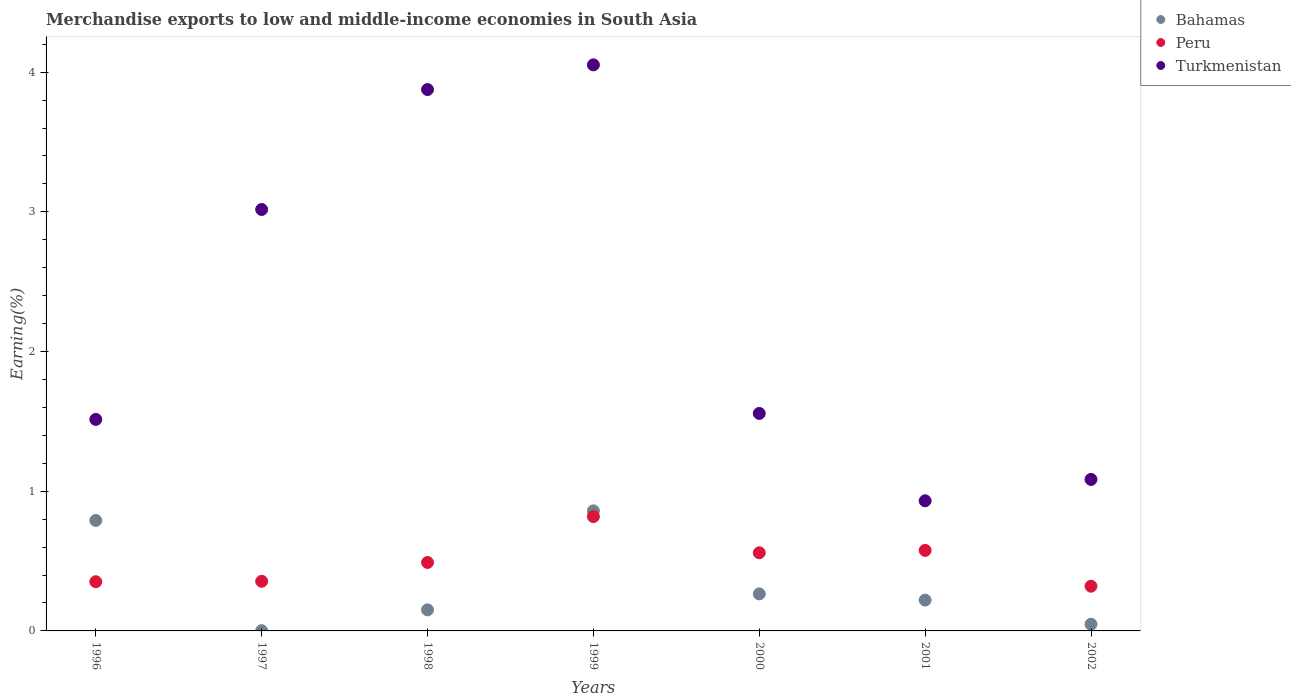How many different coloured dotlines are there?
Offer a terse response. 3. Is the number of dotlines equal to the number of legend labels?
Provide a succinct answer. Yes. What is the percentage of amount earned from merchandise exports in Peru in 1996?
Your answer should be very brief. 0.35. Across all years, what is the maximum percentage of amount earned from merchandise exports in Peru?
Keep it short and to the point. 0.82. Across all years, what is the minimum percentage of amount earned from merchandise exports in Bahamas?
Offer a terse response. 0. In which year was the percentage of amount earned from merchandise exports in Bahamas minimum?
Offer a terse response. 1997. What is the total percentage of amount earned from merchandise exports in Bahamas in the graph?
Your answer should be compact. 2.34. What is the difference between the percentage of amount earned from merchandise exports in Turkmenistan in 1996 and that in 2000?
Keep it short and to the point. -0.04. What is the difference between the percentage of amount earned from merchandise exports in Turkmenistan in 1999 and the percentage of amount earned from merchandise exports in Bahamas in 2001?
Your response must be concise. 3.83. What is the average percentage of amount earned from merchandise exports in Peru per year?
Offer a very short reply. 0.5. In the year 1999, what is the difference between the percentage of amount earned from merchandise exports in Bahamas and percentage of amount earned from merchandise exports in Peru?
Your answer should be very brief. 0.04. What is the ratio of the percentage of amount earned from merchandise exports in Turkmenistan in 1998 to that in 1999?
Offer a very short reply. 0.96. What is the difference between the highest and the second highest percentage of amount earned from merchandise exports in Bahamas?
Offer a very short reply. 0.07. What is the difference between the highest and the lowest percentage of amount earned from merchandise exports in Turkmenistan?
Make the answer very short. 3.12. Does the percentage of amount earned from merchandise exports in Turkmenistan monotonically increase over the years?
Provide a succinct answer. No. Is the percentage of amount earned from merchandise exports in Bahamas strictly less than the percentage of amount earned from merchandise exports in Turkmenistan over the years?
Provide a succinct answer. Yes. How many years are there in the graph?
Make the answer very short. 7. Does the graph contain any zero values?
Give a very brief answer. No. Where does the legend appear in the graph?
Your answer should be compact. Top right. What is the title of the graph?
Ensure brevity in your answer.  Merchandise exports to low and middle-income economies in South Asia. Does "Papua New Guinea" appear as one of the legend labels in the graph?
Make the answer very short. No. What is the label or title of the Y-axis?
Make the answer very short. Earning(%). What is the Earning(%) of Bahamas in 1996?
Provide a short and direct response. 0.79. What is the Earning(%) of Peru in 1996?
Your response must be concise. 0.35. What is the Earning(%) in Turkmenistan in 1996?
Provide a succinct answer. 1.51. What is the Earning(%) in Bahamas in 1997?
Make the answer very short. 0. What is the Earning(%) of Peru in 1997?
Give a very brief answer. 0.36. What is the Earning(%) of Turkmenistan in 1997?
Your response must be concise. 3.02. What is the Earning(%) of Bahamas in 1998?
Ensure brevity in your answer.  0.15. What is the Earning(%) of Peru in 1998?
Provide a short and direct response. 0.49. What is the Earning(%) in Turkmenistan in 1998?
Keep it short and to the point. 3.88. What is the Earning(%) of Bahamas in 1999?
Your answer should be compact. 0.86. What is the Earning(%) in Peru in 1999?
Give a very brief answer. 0.82. What is the Earning(%) in Turkmenistan in 1999?
Ensure brevity in your answer.  4.05. What is the Earning(%) of Bahamas in 2000?
Ensure brevity in your answer.  0.27. What is the Earning(%) of Peru in 2000?
Provide a short and direct response. 0.56. What is the Earning(%) in Turkmenistan in 2000?
Keep it short and to the point. 1.56. What is the Earning(%) of Bahamas in 2001?
Provide a succinct answer. 0.22. What is the Earning(%) in Peru in 2001?
Keep it short and to the point. 0.58. What is the Earning(%) in Turkmenistan in 2001?
Make the answer very short. 0.93. What is the Earning(%) of Bahamas in 2002?
Your answer should be compact. 0.05. What is the Earning(%) in Peru in 2002?
Give a very brief answer. 0.32. What is the Earning(%) in Turkmenistan in 2002?
Your answer should be compact. 1.08. Across all years, what is the maximum Earning(%) in Bahamas?
Offer a very short reply. 0.86. Across all years, what is the maximum Earning(%) of Peru?
Your answer should be very brief. 0.82. Across all years, what is the maximum Earning(%) of Turkmenistan?
Keep it short and to the point. 4.05. Across all years, what is the minimum Earning(%) of Bahamas?
Your answer should be compact. 0. Across all years, what is the minimum Earning(%) of Peru?
Your answer should be very brief. 0.32. Across all years, what is the minimum Earning(%) in Turkmenistan?
Offer a terse response. 0.93. What is the total Earning(%) in Bahamas in the graph?
Provide a short and direct response. 2.34. What is the total Earning(%) in Peru in the graph?
Offer a very short reply. 3.47. What is the total Earning(%) of Turkmenistan in the graph?
Offer a terse response. 16.03. What is the difference between the Earning(%) in Bahamas in 1996 and that in 1997?
Offer a very short reply. 0.79. What is the difference between the Earning(%) of Peru in 1996 and that in 1997?
Provide a succinct answer. -0. What is the difference between the Earning(%) of Turkmenistan in 1996 and that in 1997?
Your answer should be very brief. -1.5. What is the difference between the Earning(%) of Bahamas in 1996 and that in 1998?
Ensure brevity in your answer.  0.64. What is the difference between the Earning(%) of Peru in 1996 and that in 1998?
Provide a succinct answer. -0.14. What is the difference between the Earning(%) in Turkmenistan in 1996 and that in 1998?
Your response must be concise. -2.36. What is the difference between the Earning(%) of Bahamas in 1996 and that in 1999?
Your answer should be very brief. -0.07. What is the difference between the Earning(%) of Peru in 1996 and that in 1999?
Provide a succinct answer. -0.47. What is the difference between the Earning(%) of Turkmenistan in 1996 and that in 1999?
Ensure brevity in your answer.  -2.54. What is the difference between the Earning(%) in Bahamas in 1996 and that in 2000?
Your answer should be very brief. 0.53. What is the difference between the Earning(%) in Peru in 1996 and that in 2000?
Give a very brief answer. -0.21. What is the difference between the Earning(%) in Turkmenistan in 1996 and that in 2000?
Make the answer very short. -0.04. What is the difference between the Earning(%) of Bahamas in 1996 and that in 2001?
Your answer should be compact. 0.57. What is the difference between the Earning(%) in Peru in 1996 and that in 2001?
Ensure brevity in your answer.  -0.22. What is the difference between the Earning(%) of Turkmenistan in 1996 and that in 2001?
Offer a very short reply. 0.58. What is the difference between the Earning(%) in Bahamas in 1996 and that in 2002?
Provide a short and direct response. 0.74. What is the difference between the Earning(%) of Peru in 1996 and that in 2002?
Ensure brevity in your answer.  0.03. What is the difference between the Earning(%) in Turkmenistan in 1996 and that in 2002?
Offer a very short reply. 0.43. What is the difference between the Earning(%) in Bahamas in 1997 and that in 1998?
Your answer should be very brief. -0.15. What is the difference between the Earning(%) of Peru in 1997 and that in 1998?
Ensure brevity in your answer.  -0.13. What is the difference between the Earning(%) in Turkmenistan in 1997 and that in 1998?
Your answer should be compact. -0.86. What is the difference between the Earning(%) in Bahamas in 1997 and that in 1999?
Provide a succinct answer. -0.86. What is the difference between the Earning(%) in Peru in 1997 and that in 1999?
Offer a terse response. -0.46. What is the difference between the Earning(%) in Turkmenistan in 1997 and that in 1999?
Make the answer very short. -1.04. What is the difference between the Earning(%) in Bahamas in 1997 and that in 2000?
Keep it short and to the point. -0.26. What is the difference between the Earning(%) of Peru in 1997 and that in 2000?
Make the answer very short. -0.2. What is the difference between the Earning(%) in Turkmenistan in 1997 and that in 2000?
Your response must be concise. 1.46. What is the difference between the Earning(%) of Bahamas in 1997 and that in 2001?
Provide a succinct answer. -0.22. What is the difference between the Earning(%) in Peru in 1997 and that in 2001?
Your answer should be compact. -0.22. What is the difference between the Earning(%) of Turkmenistan in 1997 and that in 2001?
Give a very brief answer. 2.09. What is the difference between the Earning(%) of Bahamas in 1997 and that in 2002?
Provide a succinct answer. -0.05. What is the difference between the Earning(%) in Peru in 1997 and that in 2002?
Provide a succinct answer. 0.04. What is the difference between the Earning(%) in Turkmenistan in 1997 and that in 2002?
Offer a terse response. 1.93. What is the difference between the Earning(%) of Bahamas in 1998 and that in 1999?
Your answer should be compact. -0.71. What is the difference between the Earning(%) in Peru in 1998 and that in 1999?
Offer a very short reply. -0.33. What is the difference between the Earning(%) of Turkmenistan in 1998 and that in 1999?
Ensure brevity in your answer.  -0.18. What is the difference between the Earning(%) in Bahamas in 1998 and that in 2000?
Your response must be concise. -0.11. What is the difference between the Earning(%) in Peru in 1998 and that in 2000?
Keep it short and to the point. -0.07. What is the difference between the Earning(%) in Turkmenistan in 1998 and that in 2000?
Your answer should be very brief. 2.32. What is the difference between the Earning(%) of Bahamas in 1998 and that in 2001?
Ensure brevity in your answer.  -0.07. What is the difference between the Earning(%) in Peru in 1998 and that in 2001?
Your response must be concise. -0.09. What is the difference between the Earning(%) in Turkmenistan in 1998 and that in 2001?
Provide a succinct answer. 2.94. What is the difference between the Earning(%) in Bahamas in 1998 and that in 2002?
Your response must be concise. 0.1. What is the difference between the Earning(%) in Peru in 1998 and that in 2002?
Offer a very short reply. 0.17. What is the difference between the Earning(%) of Turkmenistan in 1998 and that in 2002?
Provide a succinct answer. 2.79. What is the difference between the Earning(%) of Bahamas in 1999 and that in 2000?
Your answer should be compact. 0.59. What is the difference between the Earning(%) in Peru in 1999 and that in 2000?
Your answer should be compact. 0.26. What is the difference between the Earning(%) of Turkmenistan in 1999 and that in 2000?
Keep it short and to the point. 2.5. What is the difference between the Earning(%) in Bahamas in 1999 and that in 2001?
Give a very brief answer. 0.64. What is the difference between the Earning(%) of Peru in 1999 and that in 2001?
Make the answer very short. 0.24. What is the difference between the Earning(%) of Turkmenistan in 1999 and that in 2001?
Your answer should be compact. 3.12. What is the difference between the Earning(%) of Bahamas in 1999 and that in 2002?
Make the answer very short. 0.81. What is the difference between the Earning(%) in Peru in 1999 and that in 2002?
Make the answer very short. 0.5. What is the difference between the Earning(%) in Turkmenistan in 1999 and that in 2002?
Your answer should be very brief. 2.97. What is the difference between the Earning(%) in Bahamas in 2000 and that in 2001?
Ensure brevity in your answer.  0.04. What is the difference between the Earning(%) of Peru in 2000 and that in 2001?
Ensure brevity in your answer.  -0.02. What is the difference between the Earning(%) in Turkmenistan in 2000 and that in 2001?
Provide a short and direct response. 0.63. What is the difference between the Earning(%) of Bahamas in 2000 and that in 2002?
Your answer should be compact. 0.22. What is the difference between the Earning(%) in Peru in 2000 and that in 2002?
Your answer should be compact. 0.24. What is the difference between the Earning(%) in Turkmenistan in 2000 and that in 2002?
Your answer should be compact. 0.47. What is the difference between the Earning(%) of Bahamas in 2001 and that in 2002?
Provide a succinct answer. 0.17. What is the difference between the Earning(%) of Peru in 2001 and that in 2002?
Your answer should be very brief. 0.26. What is the difference between the Earning(%) of Turkmenistan in 2001 and that in 2002?
Provide a short and direct response. -0.15. What is the difference between the Earning(%) in Bahamas in 1996 and the Earning(%) in Peru in 1997?
Your answer should be very brief. 0.44. What is the difference between the Earning(%) in Bahamas in 1996 and the Earning(%) in Turkmenistan in 1997?
Make the answer very short. -2.23. What is the difference between the Earning(%) in Peru in 1996 and the Earning(%) in Turkmenistan in 1997?
Provide a succinct answer. -2.66. What is the difference between the Earning(%) of Bahamas in 1996 and the Earning(%) of Peru in 1998?
Keep it short and to the point. 0.3. What is the difference between the Earning(%) of Bahamas in 1996 and the Earning(%) of Turkmenistan in 1998?
Provide a short and direct response. -3.08. What is the difference between the Earning(%) of Peru in 1996 and the Earning(%) of Turkmenistan in 1998?
Offer a very short reply. -3.52. What is the difference between the Earning(%) in Bahamas in 1996 and the Earning(%) in Peru in 1999?
Give a very brief answer. -0.03. What is the difference between the Earning(%) in Bahamas in 1996 and the Earning(%) in Turkmenistan in 1999?
Make the answer very short. -3.26. What is the difference between the Earning(%) in Peru in 1996 and the Earning(%) in Turkmenistan in 1999?
Give a very brief answer. -3.7. What is the difference between the Earning(%) in Bahamas in 1996 and the Earning(%) in Peru in 2000?
Offer a terse response. 0.23. What is the difference between the Earning(%) of Bahamas in 1996 and the Earning(%) of Turkmenistan in 2000?
Provide a succinct answer. -0.77. What is the difference between the Earning(%) of Peru in 1996 and the Earning(%) of Turkmenistan in 2000?
Make the answer very short. -1.2. What is the difference between the Earning(%) in Bahamas in 1996 and the Earning(%) in Peru in 2001?
Provide a short and direct response. 0.21. What is the difference between the Earning(%) in Bahamas in 1996 and the Earning(%) in Turkmenistan in 2001?
Your answer should be very brief. -0.14. What is the difference between the Earning(%) in Peru in 1996 and the Earning(%) in Turkmenistan in 2001?
Offer a very short reply. -0.58. What is the difference between the Earning(%) of Bahamas in 1996 and the Earning(%) of Peru in 2002?
Offer a very short reply. 0.47. What is the difference between the Earning(%) in Bahamas in 1996 and the Earning(%) in Turkmenistan in 2002?
Your response must be concise. -0.29. What is the difference between the Earning(%) of Peru in 1996 and the Earning(%) of Turkmenistan in 2002?
Keep it short and to the point. -0.73. What is the difference between the Earning(%) of Bahamas in 1997 and the Earning(%) of Peru in 1998?
Make the answer very short. -0.49. What is the difference between the Earning(%) of Bahamas in 1997 and the Earning(%) of Turkmenistan in 1998?
Your answer should be compact. -3.87. What is the difference between the Earning(%) in Peru in 1997 and the Earning(%) in Turkmenistan in 1998?
Your response must be concise. -3.52. What is the difference between the Earning(%) in Bahamas in 1997 and the Earning(%) in Peru in 1999?
Ensure brevity in your answer.  -0.82. What is the difference between the Earning(%) in Bahamas in 1997 and the Earning(%) in Turkmenistan in 1999?
Give a very brief answer. -4.05. What is the difference between the Earning(%) in Peru in 1997 and the Earning(%) in Turkmenistan in 1999?
Ensure brevity in your answer.  -3.7. What is the difference between the Earning(%) in Bahamas in 1997 and the Earning(%) in Peru in 2000?
Your answer should be compact. -0.56. What is the difference between the Earning(%) in Bahamas in 1997 and the Earning(%) in Turkmenistan in 2000?
Keep it short and to the point. -1.56. What is the difference between the Earning(%) of Peru in 1997 and the Earning(%) of Turkmenistan in 2000?
Your answer should be very brief. -1.2. What is the difference between the Earning(%) in Bahamas in 1997 and the Earning(%) in Peru in 2001?
Your answer should be very brief. -0.57. What is the difference between the Earning(%) in Bahamas in 1997 and the Earning(%) in Turkmenistan in 2001?
Offer a terse response. -0.93. What is the difference between the Earning(%) of Peru in 1997 and the Earning(%) of Turkmenistan in 2001?
Make the answer very short. -0.58. What is the difference between the Earning(%) in Bahamas in 1997 and the Earning(%) in Peru in 2002?
Your answer should be compact. -0.32. What is the difference between the Earning(%) in Bahamas in 1997 and the Earning(%) in Turkmenistan in 2002?
Your answer should be very brief. -1.08. What is the difference between the Earning(%) in Peru in 1997 and the Earning(%) in Turkmenistan in 2002?
Offer a terse response. -0.73. What is the difference between the Earning(%) of Bahamas in 1998 and the Earning(%) of Peru in 1999?
Provide a succinct answer. -0.67. What is the difference between the Earning(%) in Bahamas in 1998 and the Earning(%) in Turkmenistan in 1999?
Ensure brevity in your answer.  -3.9. What is the difference between the Earning(%) of Peru in 1998 and the Earning(%) of Turkmenistan in 1999?
Give a very brief answer. -3.56. What is the difference between the Earning(%) of Bahamas in 1998 and the Earning(%) of Peru in 2000?
Ensure brevity in your answer.  -0.41. What is the difference between the Earning(%) in Bahamas in 1998 and the Earning(%) in Turkmenistan in 2000?
Give a very brief answer. -1.41. What is the difference between the Earning(%) of Peru in 1998 and the Earning(%) of Turkmenistan in 2000?
Provide a succinct answer. -1.07. What is the difference between the Earning(%) of Bahamas in 1998 and the Earning(%) of Peru in 2001?
Give a very brief answer. -0.43. What is the difference between the Earning(%) of Bahamas in 1998 and the Earning(%) of Turkmenistan in 2001?
Your answer should be compact. -0.78. What is the difference between the Earning(%) in Peru in 1998 and the Earning(%) in Turkmenistan in 2001?
Offer a very short reply. -0.44. What is the difference between the Earning(%) of Bahamas in 1998 and the Earning(%) of Peru in 2002?
Your answer should be very brief. -0.17. What is the difference between the Earning(%) in Bahamas in 1998 and the Earning(%) in Turkmenistan in 2002?
Give a very brief answer. -0.93. What is the difference between the Earning(%) of Peru in 1998 and the Earning(%) of Turkmenistan in 2002?
Provide a succinct answer. -0.59. What is the difference between the Earning(%) of Bahamas in 1999 and the Earning(%) of Peru in 2000?
Ensure brevity in your answer.  0.3. What is the difference between the Earning(%) in Bahamas in 1999 and the Earning(%) in Turkmenistan in 2000?
Make the answer very short. -0.7. What is the difference between the Earning(%) in Peru in 1999 and the Earning(%) in Turkmenistan in 2000?
Your answer should be very brief. -0.74. What is the difference between the Earning(%) of Bahamas in 1999 and the Earning(%) of Peru in 2001?
Offer a terse response. 0.28. What is the difference between the Earning(%) in Bahamas in 1999 and the Earning(%) in Turkmenistan in 2001?
Provide a succinct answer. -0.07. What is the difference between the Earning(%) in Peru in 1999 and the Earning(%) in Turkmenistan in 2001?
Your answer should be compact. -0.11. What is the difference between the Earning(%) in Bahamas in 1999 and the Earning(%) in Peru in 2002?
Provide a short and direct response. 0.54. What is the difference between the Earning(%) in Bahamas in 1999 and the Earning(%) in Turkmenistan in 2002?
Your answer should be compact. -0.23. What is the difference between the Earning(%) of Peru in 1999 and the Earning(%) of Turkmenistan in 2002?
Provide a short and direct response. -0.27. What is the difference between the Earning(%) of Bahamas in 2000 and the Earning(%) of Peru in 2001?
Your response must be concise. -0.31. What is the difference between the Earning(%) of Bahamas in 2000 and the Earning(%) of Turkmenistan in 2001?
Provide a short and direct response. -0.67. What is the difference between the Earning(%) of Peru in 2000 and the Earning(%) of Turkmenistan in 2001?
Your answer should be compact. -0.37. What is the difference between the Earning(%) of Bahamas in 2000 and the Earning(%) of Peru in 2002?
Your answer should be very brief. -0.06. What is the difference between the Earning(%) in Bahamas in 2000 and the Earning(%) in Turkmenistan in 2002?
Offer a terse response. -0.82. What is the difference between the Earning(%) in Peru in 2000 and the Earning(%) in Turkmenistan in 2002?
Keep it short and to the point. -0.53. What is the difference between the Earning(%) in Bahamas in 2001 and the Earning(%) in Peru in 2002?
Offer a very short reply. -0.1. What is the difference between the Earning(%) of Bahamas in 2001 and the Earning(%) of Turkmenistan in 2002?
Your response must be concise. -0.86. What is the difference between the Earning(%) of Peru in 2001 and the Earning(%) of Turkmenistan in 2002?
Ensure brevity in your answer.  -0.51. What is the average Earning(%) in Bahamas per year?
Your answer should be very brief. 0.33. What is the average Earning(%) of Peru per year?
Your response must be concise. 0.5. What is the average Earning(%) of Turkmenistan per year?
Your response must be concise. 2.29. In the year 1996, what is the difference between the Earning(%) in Bahamas and Earning(%) in Peru?
Your answer should be compact. 0.44. In the year 1996, what is the difference between the Earning(%) of Bahamas and Earning(%) of Turkmenistan?
Your answer should be compact. -0.72. In the year 1996, what is the difference between the Earning(%) in Peru and Earning(%) in Turkmenistan?
Your answer should be very brief. -1.16. In the year 1997, what is the difference between the Earning(%) in Bahamas and Earning(%) in Peru?
Your response must be concise. -0.35. In the year 1997, what is the difference between the Earning(%) in Bahamas and Earning(%) in Turkmenistan?
Your response must be concise. -3.02. In the year 1997, what is the difference between the Earning(%) in Peru and Earning(%) in Turkmenistan?
Keep it short and to the point. -2.66. In the year 1998, what is the difference between the Earning(%) of Bahamas and Earning(%) of Peru?
Your answer should be compact. -0.34. In the year 1998, what is the difference between the Earning(%) in Bahamas and Earning(%) in Turkmenistan?
Provide a short and direct response. -3.72. In the year 1998, what is the difference between the Earning(%) of Peru and Earning(%) of Turkmenistan?
Provide a short and direct response. -3.39. In the year 1999, what is the difference between the Earning(%) in Bahamas and Earning(%) in Peru?
Your answer should be very brief. 0.04. In the year 1999, what is the difference between the Earning(%) of Bahamas and Earning(%) of Turkmenistan?
Your answer should be very brief. -3.19. In the year 1999, what is the difference between the Earning(%) in Peru and Earning(%) in Turkmenistan?
Offer a terse response. -3.23. In the year 2000, what is the difference between the Earning(%) in Bahamas and Earning(%) in Peru?
Ensure brevity in your answer.  -0.29. In the year 2000, what is the difference between the Earning(%) of Bahamas and Earning(%) of Turkmenistan?
Make the answer very short. -1.29. In the year 2000, what is the difference between the Earning(%) in Peru and Earning(%) in Turkmenistan?
Offer a very short reply. -1. In the year 2001, what is the difference between the Earning(%) in Bahamas and Earning(%) in Peru?
Make the answer very short. -0.36. In the year 2001, what is the difference between the Earning(%) of Bahamas and Earning(%) of Turkmenistan?
Make the answer very short. -0.71. In the year 2001, what is the difference between the Earning(%) of Peru and Earning(%) of Turkmenistan?
Your answer should be compact. -0.36. In the year 2002, what is the difference between the Earning(%) of Bahamas and Earning(%) of Peru?
Your answer should be very brief. -0.27. In the year 2002, what is the difference between the Earning(%) in Bahamas and Earning(%) in Turkmenistan?
Make the answer very short. -1.04. In the year 2002, what is the difference between the Earning(%) in Peru and Earning(%) in Turkmenistan?
Ensure brevity in your answer.  -0.76. What is the ratio of the Earning(%) in Bahamas in 1996 to that in 1997?
Your response must be concise. 478.17. What is the ratio of the Earning(%) of Turkmenistan in 1996 to that in 1997?
Provide a short and direct response. 0.5. What is the ratio of the Earning(%) in Bahamas in 1996 to that in 1998?
Ensure brevity in your answer.  5.25. What is the ratio of the Earning(%) of Peru in 1996 to that in 1998?
Provide a succinct answer. 0.72. What is the ratio of the Earning(%) of Turkmenistan in 1996 to that in 1998?
Your answer should be very brief. 0.39. What is the ratio of the Earning(%) of Bahamas in 1996 to that in 1999?
Keep it short and to the point. 0.92. What is the ratio of the Earning(%) in Peru in 1996 to that in 1999?
Your answer should be compact. 0.43. What is the ratio of the Earning(%) of Turkmenistan in 1996 to that in 1999?
Offer a very short reply. 0.37. What is the ratio of the Earning(%) of Bahamas in 1996 to that in 2000?
Offer a very short reply. 2.98. What is the ratio of the Earning(%) in Peru in 1996 to that in 2000?
Keep it short and to the point. 0.63. What is the ratio of the Earning(%) in Turkmenistan in 1996 to that in 2000?
Give a very brief answer. 0.97. What is the ratio of the Earning(%) in Bahamas in 1996 to that in 2001?
Provide a short and direct response. 3.58. What is the ratio of the Earning(%) in Peru in 1996 to that in 2001?
Offer a terse response. 0.61. What is the ratio of the Earning(%) of Turkmenistan in 1996 to that in 2001?
Give a very brief answer. 1.63. What is the ratio of the Earning(%) of Bahamas in 1996 to that in 2002?
Your answer should be very brief. 16.54. What is the ratio of the Earning(%) in Peru in 1996 to that in 2002?
Your answer should be compact. 1.1. What is the ratio of the Earning(%) in Turkmenistan in 1996 to that in 2002?
Provide a succinct answer. 1.4. What is the ratio of the Earning(%) in Bahamas in 1997 to that in 1998?
Provide a succinct answer. 0.01. What is the ratio of the Earning(%) in Peru in 1997 to that in 1998?
Your response must be concise. 0.73. What is the ratio of the Earning(%) of Turkmenistan in 1997 to that in 1998?
Give a very brief answer. 0.78. What is the ratio of the Earning(%) in Bahamas in 1997 to that in 1999?
Keep it short and to the point. 0. What is the ratio of the Earning(%) of Peru in 1997 to that in 1999?
Offer a very short reply. 0.43. What is the ratio of the Earning(%) in Turkmenistan in 1997 to that in 1999?
Give a very brief answer. 0.74. What is the ratio of the Earning(%) in Bahamas in 1997 to that in 2000?
Offer a terse response. 0.01. What is the ratio of the Earning(%) in Peru in 1997 to that in 2000?
Offer a very short reply. 0.64. What is the ratio of the Earning(%) of Turkmenistan in 1997 to that in 2000?
Offer a very short reply. 1.94. What is the ratio of the Earning(%) in Bahamas in 1997 to that in 2001?
Provide a succinct answer. 0.01. What is the ratio of the Earning(%) of Peru in 1997 to that in 2001?
Offer a terse response. 0.62. What is the ratio of the Earning(%) of Turkmenistan in 1997 to that in 2001?
Provide a succinct answer. 3.24. What is the ratio of the Earning(%) in Bahamas in 1997 to that in 2002?
Your answer should be very brief. 0.03. What is the ratio of the Earning(%) of Peru in 1997 to that in 2002?
Your answer should be compact. 1.11. What is the ratio of the Earning(%) of Turkmenistan in 1997 to that in 2002?
Ensure brevity in your answer.  2.78. What is the ratio of the Earning(%) in Bahamas in 1998 to that in 1999?
Provide a short and direct response. 0.18. What is the ratio of the Earning(%) of Peru in 1998 to that in 1999?
Ensure brevity in your answer.  0.6. What is the ratio of the Earning(%) of Turkmenistan in 1998 to that in 1999?
Offer a very short reply. 0.96. What is the ratio of the Earning(%) in Bahamas in 1998 to that in 2000?
Make the answer very short. 0.57. What is the ratio of the Earning(%) of Peru in 1998 to that in 2000?
Your answer should be very brief. 0.88. What is the ratio of the Earning(%) in Turkmenistan in 1998 to that in 2000?
Ensure brevity in your answer.  2.49. What is the ratio of the Earning(%) in Bahamas in 1998 to that in 2001?
Offer a terse response. 0.68. What is the ratio of the Earning(%) in Peru in 1998 to that in 2001?
Provide a succinct answer. 0.85. What is the ratio of the Earning(%) of Turkmenistan in 1998 to that in 2001?
Your answer should be very brief. 4.16. What is the ratio of the Earning(%) in Bahamas in 1998 to that in 2002?
Make the answer very short. 3.15. What is the ratio of the Earning(%) in Peru in 1998 to that in 2002?
Your answer should be compact. 1.53. What is the ratio of the Earning(%) of Turkmenistan in 1998 to that in 2002?
Make the answer very short. 3.57. What is the ratio of the Earning(%) in Bahamas in 1999 to that in 2000?
Your answer should be very brief. 3.24. What is the ratio of the Earning(%) in Peru in 1999 to that in 2000?
Make the answer very short. 1.46. What is the ratio of the Earning(%) of Turkmenistan in 1999 to that in 2000?
Ensure brevity in your answer.  2.6. What is the ratio of the Earning(%) of Bahamas in 1999 to that in 2001?
Your answer should be very brief. 3.89. What is the ratio of the Earning(%) of Peru in 1999 to that in 2001?
Offer a very short reply. 1.42. What is the ratio of the Earning(%) in Turkmenistan in 1999 to that in 2001?
Your response must be concise. 4.35. What is the ratio of the Earning(%) in Bahamas in 1999 to that in 2002?
Ensure brevity in your answer.  17.97. What is the ratio of the Earning(%) in Peru in 1999 to that in 2002?
Provide a short and direct response. 2.56. What is the ratio of the Earning(%) of Turkmenistan in 1999 to that in 2002?
Give a very brief answer. 3.74. What is the ratio of the Earning(%) in Bahamas in 2000 to that in 2001?
Your response must be concise. 1.2. What is the ratio of the Earning(%) in Peru in 2000 to that in 2001?
Your response must be concise. 0.97. What is the ratio of the Earning(%) of Turkmenistan in 2000 to that in 2001?
Your answer should be compact. 1.67. What is the ratio of the Earning(%) of Bahamas in 2000 to that in 2002?
Offer a terse response. 5.54. What is the ratio of the Earning(%) of Peru in 2000 to that in 2002?
Your answer should be very brief. 1.75. What is the ratio of the Earning(%) in Turkmenistan in 2000 to that in 2002?
Make the answer very short. 1.44. What is the ratio of the Earning(%) of Bahamas in 2001 to that in 2002?
Your response must be concise. 4.62. What is the ratio of the Earning(%) in Peru in 2001 to that in 2002?
Make the answer very short. 1.8. What is the ratio of the Earning(%) in Turkmenistan in 2001 to that in 2002?
Keep it short and to the point. 0.86. What is the difference between the highest and the second highest Earning(%) in Bahamas?
Provide a succinct answer. 0.07. What is the difference between the highest and the second highest Earning(%) of Peru?
Provide a short and direct response. 0.24. What is the difference between the highest and the second highest Earning(%) in Turkmenistan?
Offer a terse response. 0.18. What is the difference between the highest and the lowest Earning(%) in Bahamas?
Provide a succinct answer. 0.86. What is the difference between the highest and the lowest Earning(%) of Peru?
Offer a terse response. 0.5. What is the difference between the highest and the lowest Earning(%) in Turkmenistan?
Ensure brevity in your answer.  3.12. 